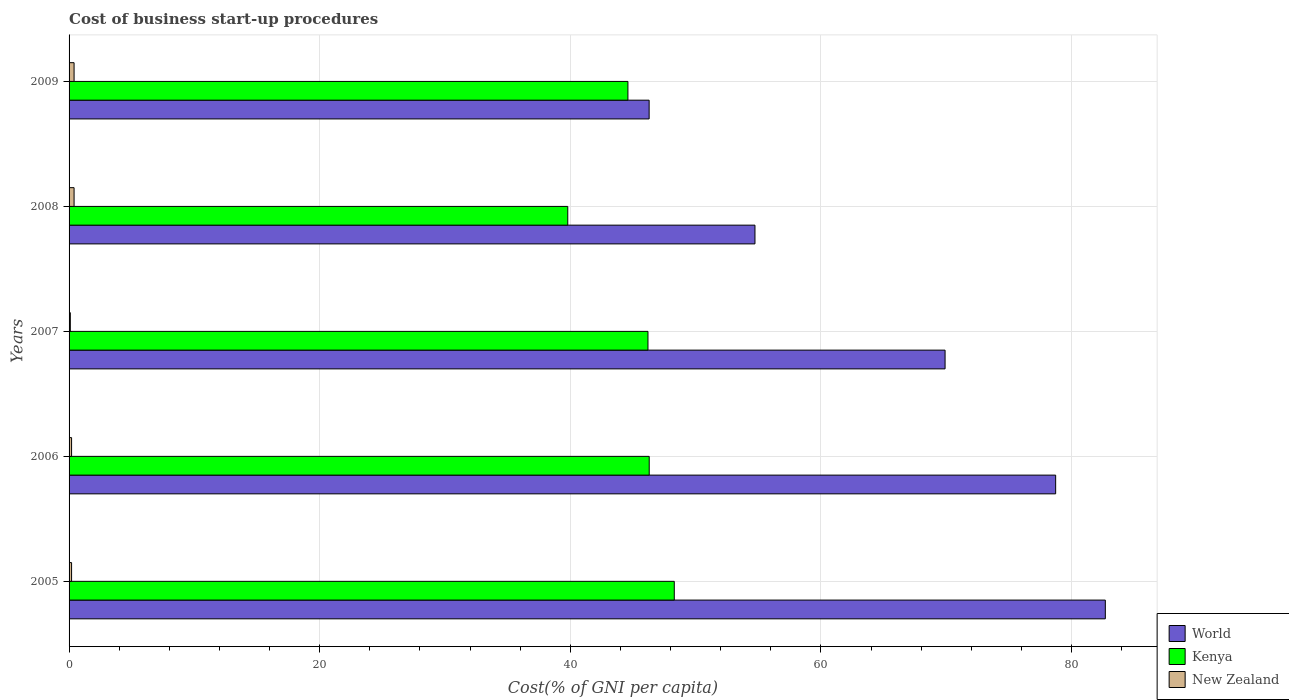Are the number of bars per tick equal to the number of legend labels?
Your answer should be compact. Yes. How many bars are there on the 1st tick from the bottom?
Ensure brevity in your answer.  3. In how many cases, is the number of bars for a given year not equal to the number of legend labels?
Provide a succinct answer. 0. What is the cost of business start-up procedures in Kenya in 2005?
Your answer should be compact. 48.3. Across all years, what is the maximum cost of business start-up procedures in New Zealand?
Give a very brief answer. 0.4. Across all years, what is the minimum cost of business start-up procedures in World?
Offer a terse response. 46.29. In which year was the cost of business start-up procedures in World maximum?
Give a very brief answer. 2005. In which year was the cost of business start-up procedures in World minimum?
Your answer should be compact. 2009. What is the total cost of business start-up procedures in World in the graph?
Make the answer very short. 332.38. What is the difference between the cost of business start-up procedures in Kenya in 2005 and that in 2008?
Make the answer very short. 8.5. What is the difference between the cost of business start-up procedures in Kenya in 2005 and the cost of business start-up procedures in New Zealand in 2008?
Offer a terse response. 47.9. What is the average cost of business start-up procedures in World per year?
Offer a terse response. 66.48. In the year 2006, what is the difference between the cost of business start-up procedures in New Zealand and cost of business start-up procedures in World?
Ensure brevity in your answer.  -78.54. In how many years, is the cost of business start-up procedures in World greater than 52 %?
Provide a short and direct response. 4. What is the ratio of the cost of business start-up procedures in World in 2005 to that in 2007?
Your answer should be very brief. 1.18. What is the difference between the highest and the second highest cost of business start-up procedures in World?
Make the answer very short. 3.96. What is the difference between the highest and the lowest cost of business start-up procedures in Kenya?
Keep it short and to the point. 8.5. What does the 3rd bar from the top in 2009 represents?
Keep it short and to the point. World. What does the 3rd bar from the bottom in 2007 represents?
Your answer should be very brief. New Zealand. Is it the case that in every year, the sum of the cost of business start-up procedures in New Zealand and cost of business start-up procedures in Kenya is greater than the cost of business start-up procedures in World?
Make the answer very short. No. What is the difference between two consecutive major ticks on the X-axis?
Provide a succinct answer. 20. Does the graph contain any zero values?
Offer a very short reply. No. Does the graph contain grids?
Provide a succinct answer. Yes. Where does the legend appear in the graph?
Provide a succinct answer. Bottom right. How many legend labels are there?
Make the answer very short. 3. What is the title of the graph?
Offer a very short reply. Cost of business start-up procedures. Does "Tajikistan" appear as one of the legend labels in the graph?
Your answer should be compact. No. What is the label or title of the X-axis?
Ensure brevity in your answer.  Cost(% of GNI per capita). What is the label or title of the Y-axis?
Give a very brief answer. Years. What is the Cost(% of GNI per capita) in World in 2005?
Ensure brevity in your answer.  82.7. What is the Cost(% of GNI per capita) in Kenya in 2005?
Offer a terse response. 48.3. What is the Cost(% of GNI per capita) of World in 2006?
Offer a very short reply. 78.74. What is the Cost(% of GNI per capita) in Kenya in 2006?
Ensure brevity in your answer.  46.3. What is the Cost(% of GNI per capita) of World in 2007?
Provide a succinct answer. 69.91. What is the Cost(% of GNI per capita) in Kenya in 2007?
Keep it short and to the point. 46.2. What is the Cost(% of GNI per capita) in World in 2008?
Ensure brevity in your answer.  54.74. What is the Cost(% of GNI per capita) of Kenya in 2008?
Provide a short and direct response. 39.8. What is the Cost(% of GNI per capita) in New Zealand in 2008?
Make the answer very short. 0.4. What is the Cost(% of GNI per capita) in World in 2009?
Provide a short and direct response. 46.29. What is the Cost(% of GNI per capita) of Kenya in 2009?
Your answer should be compact. 44.6. What is the Cost(% of GNI per capita) in New Zealand in 2009?
Your answer should be compact. 0.4. Across all years, what is the maximum Cost(% of GNI per capita) of World?
Provide a succinct answer. 82.7. Across all years, what is the maximum Cost(% of GNI per capita) in Kenya?
Provide a succinct answer. 48.3. Across all years, what is the minimum Cost(% of GNI per capita) in World?
Give a very brief answer. 46.29. Across all years, what is the minimum Cost(% of GNI per capita) in Kenya?
Offer a very short reply. 39.8. What is the total Cost(% of GNI per capita) of World in the graph?
Give a very brief answer. 332.38. What is the total Cost(% of GNI per capita) of Kenya in the graph?
Make the answer very short. 225.2. What is the total Cost(% of GNI per capita) of New Zealand in the graph?
Offer a terse response. 1.3. What is the difference between the Cost(% of GNI per capita) of World in 2005 and that in 2006?
Keep it short and to the point. 3.96. What is the difference between the Cost(% of GNI per capita) of Kenya in 2005 and that in 2006?
Keep it short and to the point. 2. What is the difference between the Cost(% of GNI per capita) of World in 2005 and that in 2007?
Make the answer very short. 12.79. What is the difference between the Cost(% of GNI per capita) of Kenya in 2005 and that in 2007?
Ensure brevity in your answer.  2.1. What is the difference between the Cost(% of GNI per capita) in New Zealand in 2005 and that in 2007?
Your response must be concise. 0.1. What is the difference between the Cost(% of GNI per capita) in World in 2005 and that in 2008?
Provide a short and direct response. 27.96. What is the difference between the Cost(% of GNI per capita) in World in 2005 and that in 2009?
Provide a short and direct response. 36.41. What is the difference between the Cost(% of GNI per capita) in Kenya in 2005 and that in 2009?
Provide a short and direct response. 3.7. What is the difference between the Cost(% of GNI per capita) in World in 2006 and that in 2007?
Give a very brief answer. 8.82. What is the difference between the Cost(% of GNI per capita) of New Zealand in 2006 and that in 2007?
Your answer should be compact. 0.1. What is the difference between the Cost(% of GNI per capita) of World in 2006 and that in 2008?
Provide a succinct answer. 24. What is the difference between the Cost(% of GNI per capita) of New Zealand in 2006 and that in 2008?
Offer a terse response. -0.2. What is the difference between the Cost(% of GNI per capita) of World in 2006 and that in 2009?
Give a very brief answer. 32.44. What is the difference between the Cost(% of GNI per capita) of New Zealand in 2006 and that in 2009?
Give a very brief answer. -0.2. What is the difference between the Cost(% of GNI per capita) of World in 2007 and that in 2008?
Ensure brevity in your answer.  15.17. What is the difference between the Cost(% of GNI per capita) of World in 2007 and that in 2009?
Give a very brief answer. 23.62. What is the difference between the Cost(% of GNI per capita) of New Zealand in 2007 and that in 2009?
Give a very brief answer. -0.3. What is the difference between the Cost(% of GNI per capita) in World in 2008 and that in 2009?
Make the answer very short. 8.45. What is the difference between the Cost(% of GNI per capita) in Kenya in 2008 and that in 2009?
Keep it short and to the point. -4.8. What is the difference between the Cost(% of GNI per capita) of New Zealand in 2008 and that in 2009?
Offer a terse response. 0. What is the difference between the Cost(% of GNI per capita) in World in 2005 and the Cost(% of GNI per capita) in Kenya in 2006?
Give a very brief answer. 36.4. What is the difference between the Cost(% of GNI per capita) in World in 2005 and the Cost(% of GNI per capita) in New Zealand in 2006?
Your answer should be compact. 82.5. What is the difference between the Cost(% of GNI per capita) in Kenya in 2005 and the Cost(% of GNI per capita) in New Zealand in 2006?
Make the answer very short. 48.1. What is the difference between the Cost(% of GNI per capita) in World in 2005 and the Cost(% of GNI per capita) in Kenya in 2007?
Ensure brevity in your answer.  36.5. What is the difference between the Cost(% of GNI per capita) in World in 2005 and the Cost(% of GNI per capita) in New Zealand in 2007?
Give a very brief answer. 82.6. What is the difference between the Cost(% of GNI per capita) of Kenya in 2005 and the Cost(% of GNI per capita) of New Zealand in 2007?
Make the answer very short. 48.2. What is the difference between the Cost(% of GNI per capita) in World in 2005 and the Cost(% of GNI per capita) in Kenya in 2008?
Keep it short and to the point. 42.9. What is the difference between the Cost(% of GNI per capita) in World in 2005 and the Cost(% of GNI per capita) in New Zealand in 2008?
Make the answer very short. 82.3. What is the difference between the Cost(% of GNI per capita) in Kenya in 2005 and the Cost(% of GNI per capita) in New Zealand in 2008?
Provide a short and direct response. 47.9. What is the difference between the Cost(% of GNI per capita) of World in 2005 and the Cost(% of GNI per capita) of Kenya in 2009?
Offer a very short reply. 38.1. What is the difference between the Cost(% of GNI per capita) of World in 2005 and the Cost(% of GNI per capita) of New Zealand in 2009?
Your response must be concise. 82.3. What is the difference between the Cost(% of GNI per capita) in Kenya in 2005 and the Cost(% of GNI per capita) in New Zealand in 2009?
Your answer should be compact. 47.9. What is the difference between the Cost(% of GNI per capita) in World in 2006 and the Cost(% of GNI per capita) in Kenya in 2007?
Ensure brevity in your answer.  32.54. What is the difference between the Cost(% of GNI per capita) of World in 2006 and the Cost(% of GNI per capita) of New Zealand in 2007?
Offer a terse response. 78.64. What is the difference between the Cost(% of GNI per capita) in Kenya in 2006 and the Cost(% of GNI per capita) in New Zealand in 2007?
Make the answer very short. 46.2. What is the difference between the Cost(% of GNI per capita) of World in 2006 and the Cost(% of GNI per capita) of Kenya in 2008?
Keep it short and to the point. 38.94. What is the difference between the Cost(% of GNI per capita) of World in 2006 and the Cost(% of GNI per capita) of New Zealand in 2008?
Ensure brevity in your answer.  78.34. What is the difference between the Cost(% of GNI per capita) in Kenya in 2006 and the Cost(% of GNI per capita) in New Zealand in 2008?
Your response must be concise. 45.9. What is the difference between the Cost(% of GNI per capita) in World in 2006 and the Cost(% of GNI per capita) in Kenya in 2009?
Keep it short and to the point. 34.14. What is the difference between the Cost(% of GNI per capita) of World in 2006 and the Cost(% of GNI per capita) of New Zealand in 2009?
Offer a very short reply. 78.34. What is the difference between the Cost(% of GNI per capita) of Kenya in 2006 and the Cost(% of GNI per capita) of New Zealand in 2009?
Offer a terse response. 45.9. What is the difference between the Cost(% of GNI per capita) in World in 2007 and the Cost(% of GNI per capita) in Kenya in 2008?
Make the answer very short. 30.11. What is the difference between the Cost(% of GNI per capita) in World in 2007 and the Cost(% of GNI per capita) in New Zealand in 2008?
Offer a terse response. 69.51. What is the difference between the Cost(% of GNI per capita) of Kenya in 2007 and the Cost(% of GNI per capita) of New Zealand in 2008?
Ensure brevity in your answer.  45.8. What is the difference between the Cost(% of GNI per capita) in World in 2007 and the Cost(% of GNI per capita) in Kenya in 2009?
Provide a short and direct response. 25.31. What is the difference between the Cost(% of GNI per capita) in World in 2007 and the Cost(% of GNI per capita) in New Zealand in 2009?
Your answer should be compact. 69.51. What is the difference between the Cost(% of GNI per capita) of Kenya in 2007 and the Cost(% of GNI per capita) of New Zealand in 2009?
Offer a terse response. 45.8. What is the difference between the Cost(% of GNI per capita) of World in 2008 and the Cost(% of GNI per capita) of Kenya in 2009?
Make the answer very short. 10.14. What is the difference between the Cost(% of GNI per capita) of World in 2008 and the Cost(% of GNI per capita) of New Zealand in 2009?
Your response must be concise. 54.34. What is the difference between the Cost(% of GNI per capita) of Kenya in 2008 and the Cost(% of GNI per capita) of New Zealand in 2009?
Your response must be concise. 39.4. What is the average Cost(% of GNI per capita) in World per year?
Your answer should be very brief. 66.48. What is the average Cost(% of GNI per capita) of Kenya per year?
Your answer should be compact. 45.04. What is the average Cost(% of GNI per capita) of New Zealand per year?
Your answer should be very brief. 0.26. In the year 2005, what is the difference between the Cost(% of GNI per capita) in World and Cost(% of GNI per capita) in Kenya?
Keep it short and to the point. 34.4. In the year 2005, what is the difference between the Cost(% of GNI per capita) of World and Cost(% of GNI per capita) of New Zealand?
Offer a very short reply. 82.5. In the year 2005, what is the difference between the Cost(% of GNI per capita) of Kenya and Cost(% of GNI per capita) of New Zealand?
Make the answer very short. 48.1. In the year 2006, what is the difference between the Cost(% of GNI per capita) of World and Cost(% of GNI per capita) of Kenya?
Provide a short and direct response. 32.44. In the year 2006, what is the difference between the Cost(% of GNI per capita) in World and Cost(% of GNI per capita) in New Zealand?
Your answer should be compact. 78.54. In the year 2006, what is the difference between the Cost(% of GNI per capita) of Kenya and Cost(% of GNI per capita) of New Zealand?
Your answer should be very brief. 46.1. In the year 2007, what is the difference between the Cost(% of GNI per capita) of World and Cost(% of GNI per capita) of Kenya?
Offer a very short reply. 23.71. In the year 2007, what is the difference between the Cost(% of GNI per capita) in World and Cost(% of GNI per capita) in New Zealand?
Your answer should be very brief. 69.81. In the year 2007, what is the difference between the Cost(% of GNI per capita) of Kenya and Cost(% of GNI per capita) of New Zealand?
Ensure brevity in your answer.  46.1. In the year 2008, what is the difference between the Cost(% of GNI per capita) of World and Cost(% of GNI per capita) of Kenya?
Give a very brief answer. 14.94. In the year 2008, what is the difference between the Cost(% of GNI per capita) of World and Cost(% of GNI per capita) of New Zealand?
Your response must be concise. 54.34. In the year 2008, what is the difference between the Cost(% of GNI per capita) of Kenya and Cost(% of GNI per capita) of New Zealand?
Offer a terse response. 39.4. In the year 2009, what is the difference between the Cost(% of GNI per capita) in World and Cost(% of GNI per capita) in Kenya?
Keep it short and to the point. 1.69. In the year 2009, what is the difference between the Cost(% of GNI per capita) in World and Cost(% of GNI per capita) in New Zealand?
Offer a terse response. 45.89. In the year 2009, what is the difference between the Cost(% of GNI per capita) in Kenya and Cost(% of GNI per capita) in New Zealand?
Offer a terse response. 44.2. What is the ratio of the Cost(% of GNI per capita) of World in 2005 to that in 2006?
Provide a succinct answer. 1.05. What is the ratio of the Cost(% of GNI per capita) of Kenya in 2005 to that in 2006?
Make the answer very short. 1.04. What is the ratio of the Cost(% of GNI per capita) in World in 2005 to that in 2007?
Provide a short and direct response. 1.18. What is the ratio of the Cost(% of GNI per capita) in Kenya in 2005 to that in 2007?
Offer a terse response. 1.05. What is the ratio of the Cost(% of GNI per capita) of New Zealand in 2005 to that in 2007?
Your answer should be compact. 2. What is the ratio of the Cost(% of GNI per capita) in World in 2005 to that in 2008?
Your answer should be compact. 1.51. What is the ratio of the Cost(% of GNI per capita) of Kenya in 2005 to that in 2008?
Make the answer very short. 1.21. What is the ratio of the Cost(% of GNI per capita) of World in 2005 to that in 2009?
Keep it short and to the point. 1.79. What is the ratio of the Cost(% of GNI per capita) of Kenya in 2005 to that in 2009?
Provide a short and direct response. 1.08. What is the ratio of the Cost(% of GNI per capita) of World in 2006 to that in 2007?
Ensure brevity in your answer.  1.13. What is the ratio of the Cost(% of GNI per capita) in Kenya in 2006 to that in 2007?
Your response must be concise. 1. What is the ratio of the Cost(% of GNI per capita) of New Zealand in 2006 to that in 2007?
Your answer should be compact. 2. What is the ratio of the Cost(% of GNI per capita) of World in 2006 to that in 2008?
Offer a very short reply. 1.44. What is the ratio of the Cost(% of GNI per capita) in Kenya in 2006 to that in 2008?
Provide a succinct answer. 1.16. What is the ratio of the Cost(% of GNI per capita) in World in 2006 to that in 2009?
Offer a terse response. 1.7. What is the ratio of the Cost(% of GNI per capita) in Kenya in 2006 to that in 2009?
Provide a short and direct response. 1.04. What is the ratio of the Cost(% of GNI per capita) in New Zealand in 2006 to that in 2009?
Keep it short and to the point. 0.5. What is the ratio of the Cost(% of GNI per capita) in World in 2007 to that in 2008?
Provide a succinct answer. 1.28. What is the ratio of the Cost(% of GNI per capita) in Kenya in 2007 to that in 2008?
Your answer should be very brief. 1.16. What is the ratio of the Cost(% of GNI per capita) of New Zealand in 2007 to that in 2008?
Provide a succinct answer. 0.25. What is the ratio of the Cost(% of GNI per capita) in World in 2007 to that in 2009?
Provide a short and direct response. 1.51. What is the ratio of the Cost(% of GNI per capita) in Kenya in 2007 to that in 2009?
Ensure brevity in your answer.  1.04. What is the ratio of the Cost(% of GNI per capita) of World in 2008 to that in 2009?
Provide a short and direct response. 1.18. What is the ratio of the Cost(% of GNI per capita) of Kenya in 2008 to that in 2009?
Offer a very short reply. 0.89. What is the difference between the highest and the second highest Cost(% of GNI per capita) of World?
Your answer should be very brief. 3.96. What is the difference between the highest and the lowest Cost(% of GNI per capita) in World?
Provide a short and direct response. 36.41. What is the difference between the highest and the lowest Cost(% of GNI per capita) of Kenya?
Your response must be concise. 8.5. What is the difference between the highest and the lowest Cost(% of GNI per capita) in New Zealand?
Offer a very short reply. 0.3. 